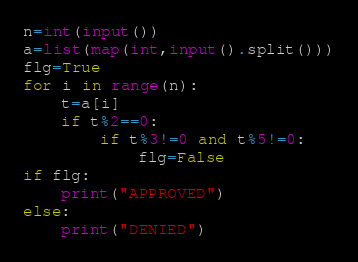Convert code to text. <code><loc_0><loc_0><loc_500><loc_500><_Python_>n=int(input())
a=list(map(int,input().split()))
flg=True
for i in range(n):
    t=a[i]
    if t%2==0:
        if t%3!=0 and t%5!=0:
            flg=False
if flg:
    print("APPROVED")
else:
    print("DENIED")</code> 